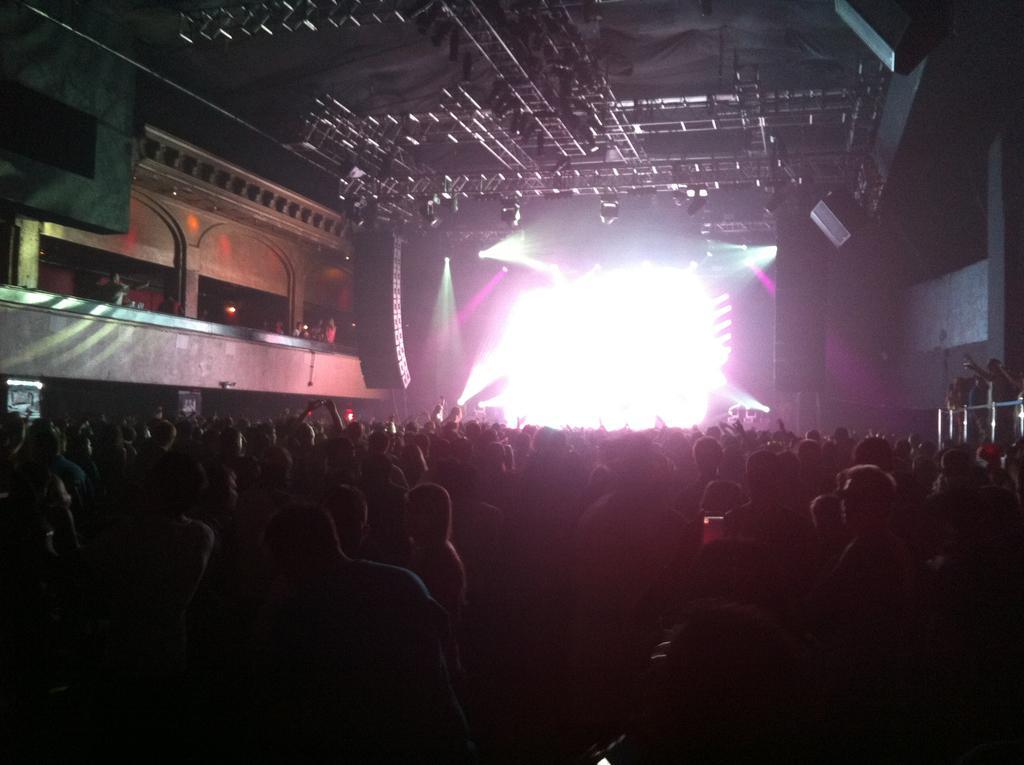Can you describe this image briefly? In front of the image there are people. On the left side of the image there are a few people standing by holding the railing. On the left side of the image there are people standing inside the building. In the background of the image there is a screen. There are speakers. At the top of the image there is a roof supported by metal rods. 